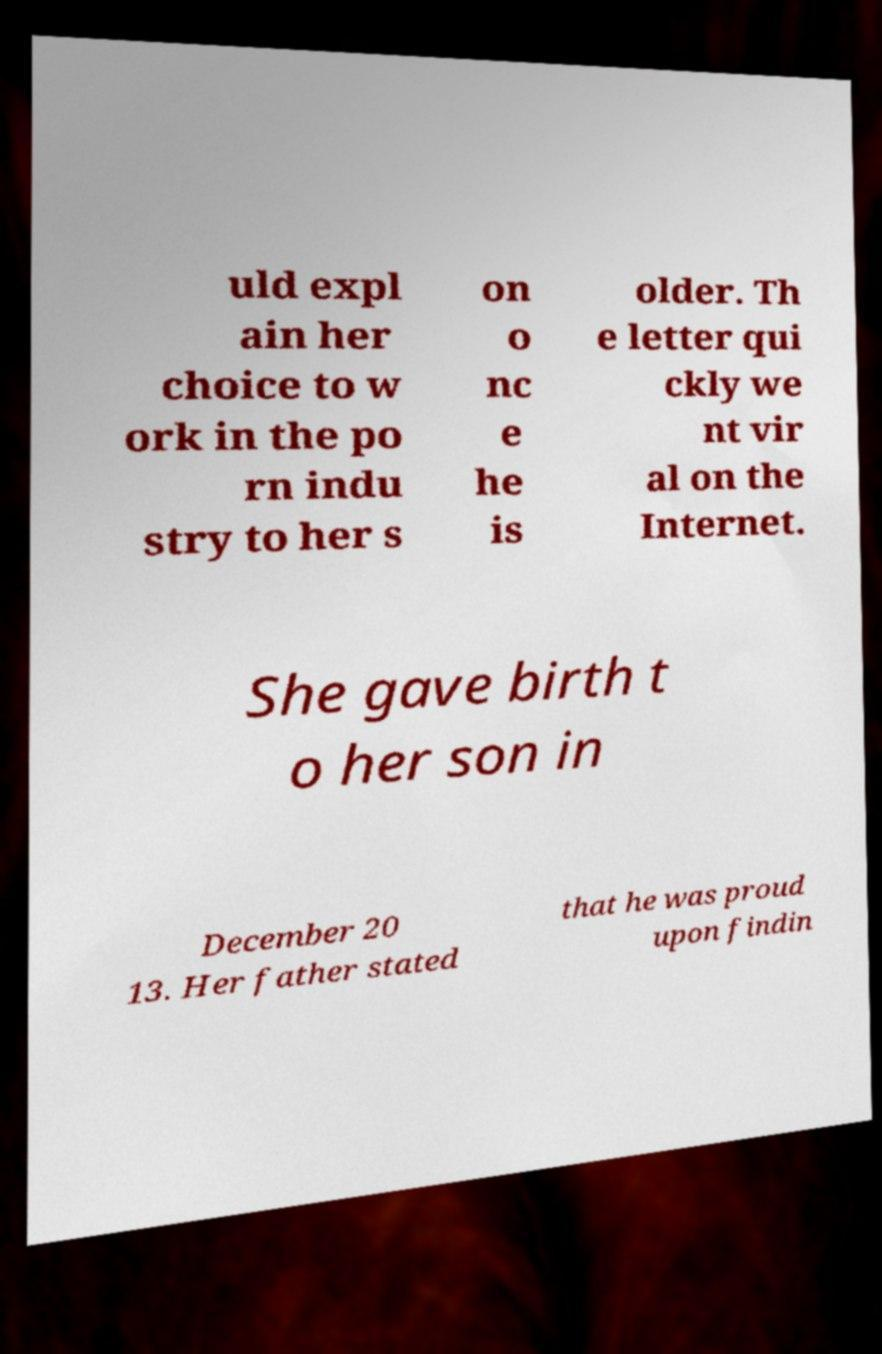Please read and relay the text visible in this image. What does it say? uld expl ain her choice to w ork in the po rn indu stry to her s on o nc e he is older. Th e letter qui ckly we nt vir al on the Internet. She gave birth t o her son in December 20 13. Her father stated that he was proud upon findin 